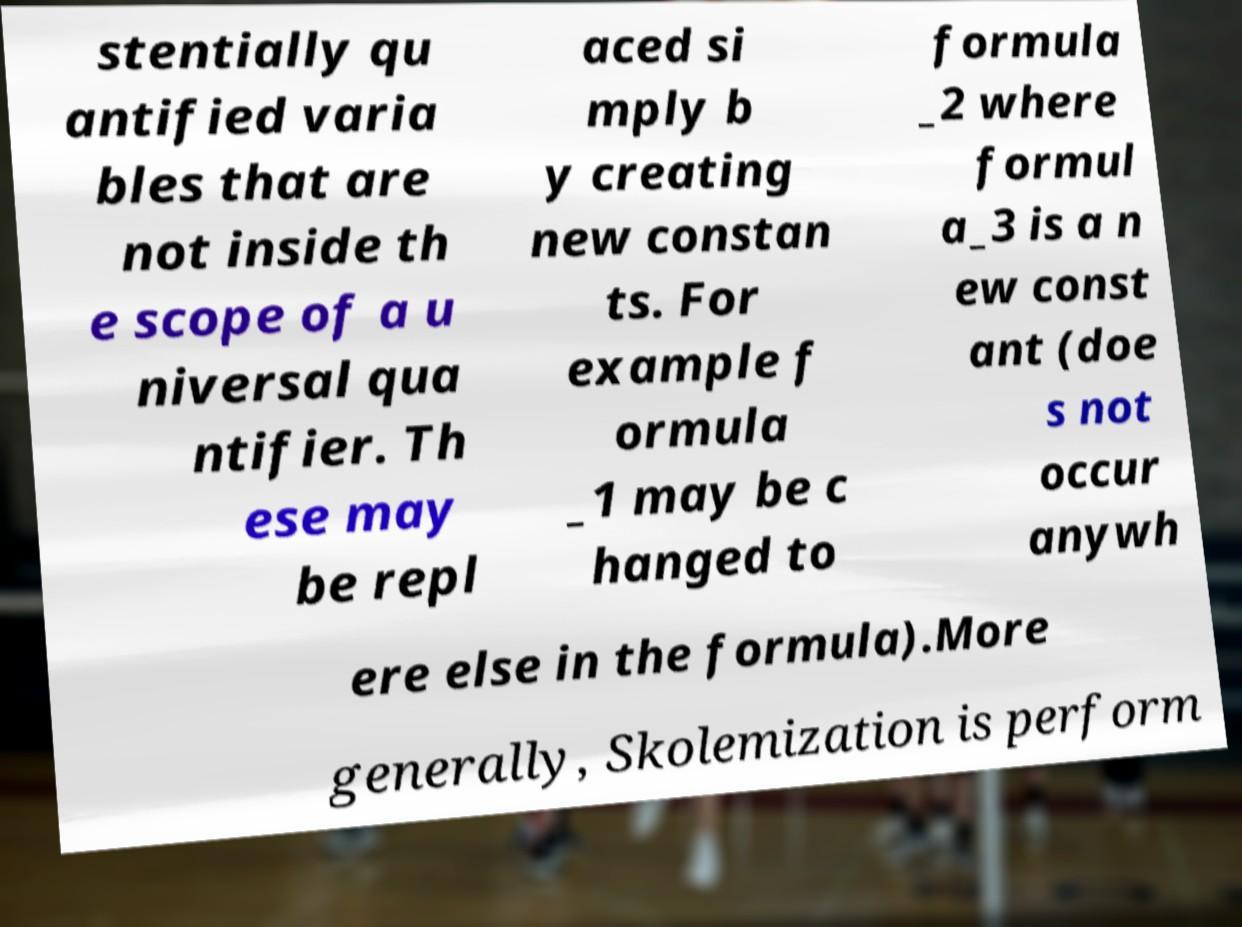Can you accurately transcribe the text from the provided image for me? stentially qu antified varia bles that are not inside th e scope of a u niversal qua ntifier. Th ese may be repl aced si mply b y creating new constan ts. For example f ormula _1 may be c hanged to formula _2 where formul a_3 is a n ew const ant (doe s not occur anywh ere else in the formula).More generally, Skolemization is perform 